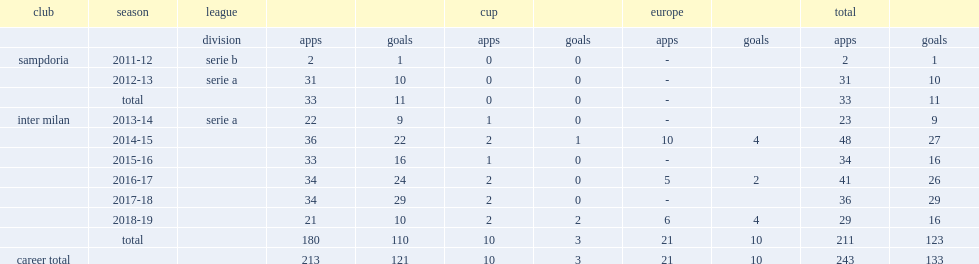Which club did mauro play for in 2012-13? Sampdoria. 